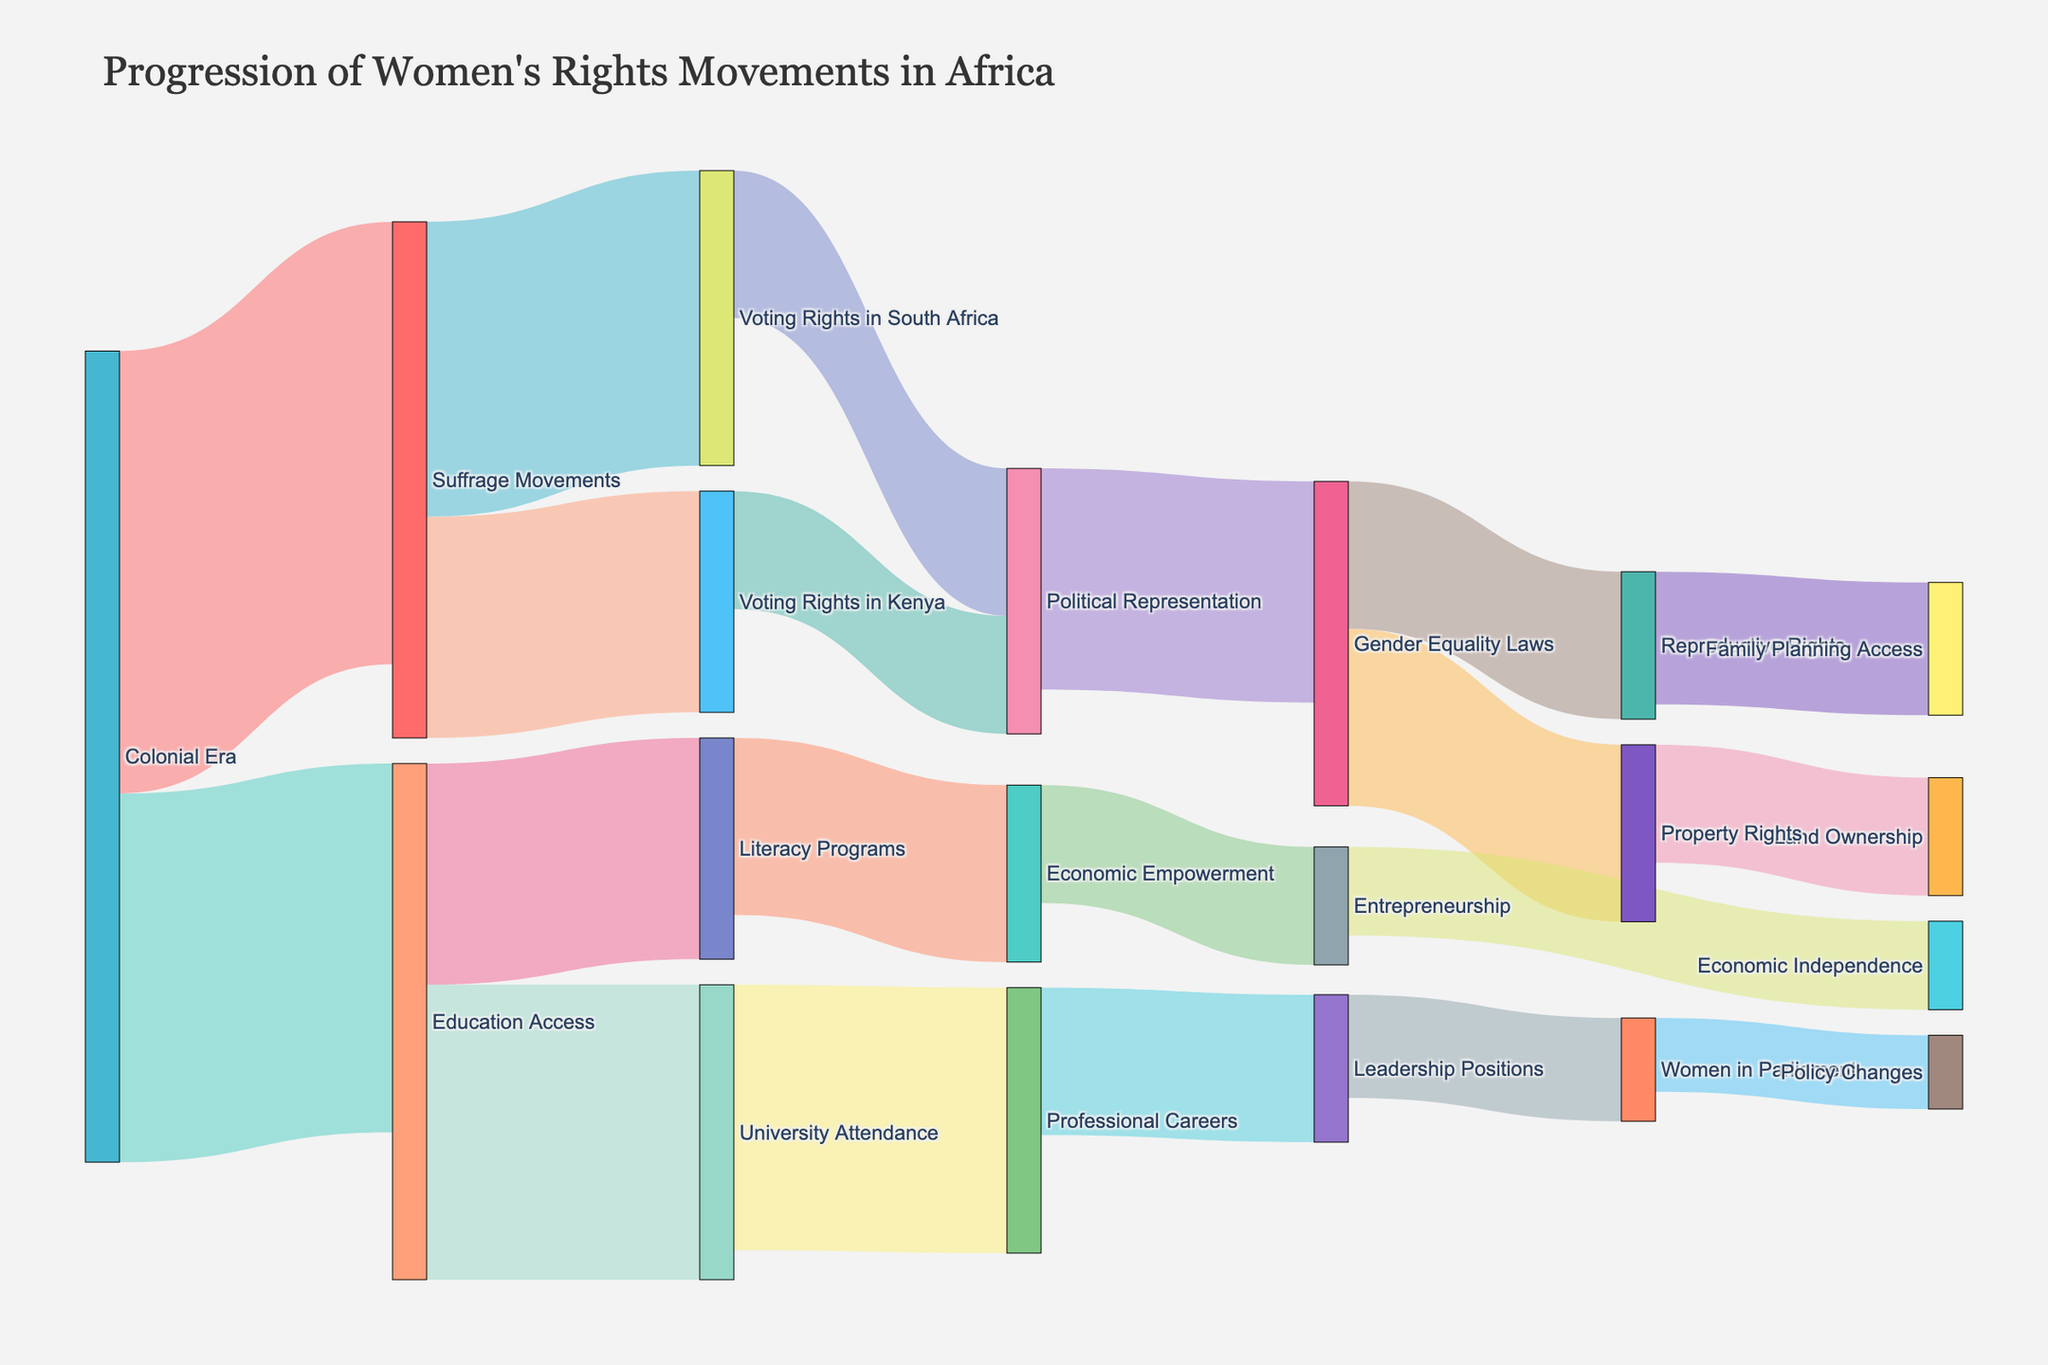What is the title of the Sankey Diagram? The title of the figure is usually located at the top of the diagram. In this case, it reads "Progression of Women's Rights Movements in Africa."
Answer: Progression of Women's Rights Movements in Africa How many connections are there from the "Colonial Era"? The connections from any node can be counted by observing the links originating from that node. Here, the "Colonial Era" has two connections: to "Suffrage Movements" and "Education Access."
Answer: 2 Which destination does "Voting Rights in South Africa" lead to? Trace the line from "Voting Rights in South Africa" to see where it connects. It connects to "Political Representation."
Answer: Political Representation What is the total value flowing into "Political Representation"? Add the values of the links flowing into the "Political Representation" node. These are 10 from "Voting Rights in South Africa" and 8 from "Voting Rights in Kenya", summing to 18.
Answer: 18 Which node has the highest number of incoming connections, and how many are there? By counting the number of links ending at each node, "Gender Equality Laws" has connections from "Political Representation" and "Economic Empowerment," totaling 2.
Answer: Gender Equality Laws, 2 How much value flows from "Education Access" to "Literacy Programs"? Identify the link from "Education Access" to "Literacy Programs" and read the value associated with it, which is 15.
Answer: 15 Which has a higher value: "University Attendance" to "Professional Careers" or "Literacy Programs" to "Economic Empowerment"? Compare the values of the connections: "University Attendance" to "Professional Careers" is 18, and "Literacy Programs" to "Economic Empowerment" is 12, making the former higher.
Answer: University Attendance to Professional Careers Summarize the progression from "Colonial Era" to "Voting Rights in Kenya" in terms of value transfer. First, observe the value from "Colonial Era" to "Suffrage Movements" (30), then from "Suffrage Movements" to "Voting Rights in Kenya" (15). The complete progression transfers 15 units.
Answer: 15 Identify all final nodes in the diagram and their values. Final nodes have no outgoing connections. They are "Family Planning Access" (9), "Land Ownership" (8), "Policy Changes" (5), "Economic Independence" (6), and "Women in Parliament (7)."
Answer: Family Planning Access (9), Land Ownership (8), Policy Changes (5), Economic Independence (6), Women in Parliament (7) Is there a direct connection from "Economic Empowerment" to any node? If so, which and what is the value? Follow the links from "Economic Empowerment" and check if it connects directly to any node. It leads to "Entrepreneurship" with a value of 8.
Answer: Yes, Entrepreneurship, 8 